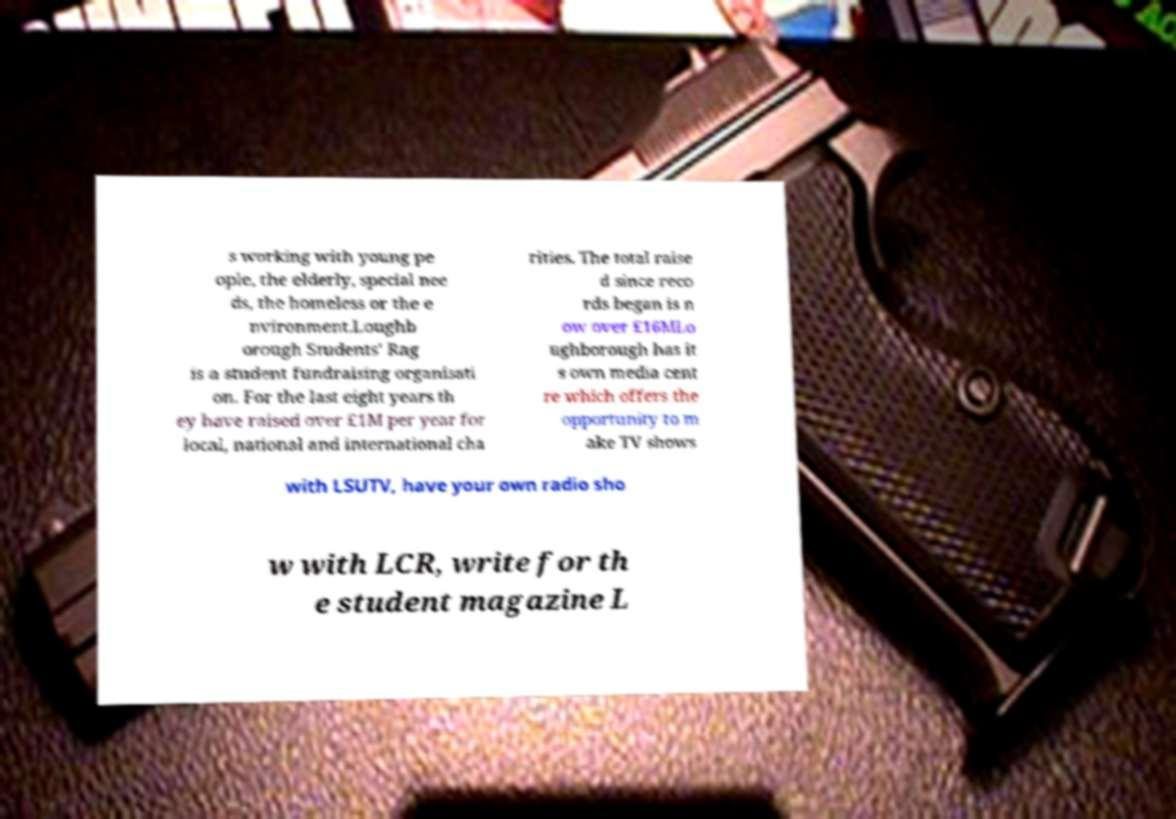I need the written content from this picture converted into text. Can you do that? s working with young pe ople, the elderly, special nee ds, the homeless or the e nvironment.Loughb orough Students' Rag is a student fundraising organisati on. For the last eight years th ey have raised over £1M per year for local, national and international cha rities. The total raise d since reco rds began is n ow over £16MLo ughborough has it s own media cent re which offers the opportunity to m ake TV shows with LSUTV, have your own radio sho w with LCR, write for th e student magazine L 